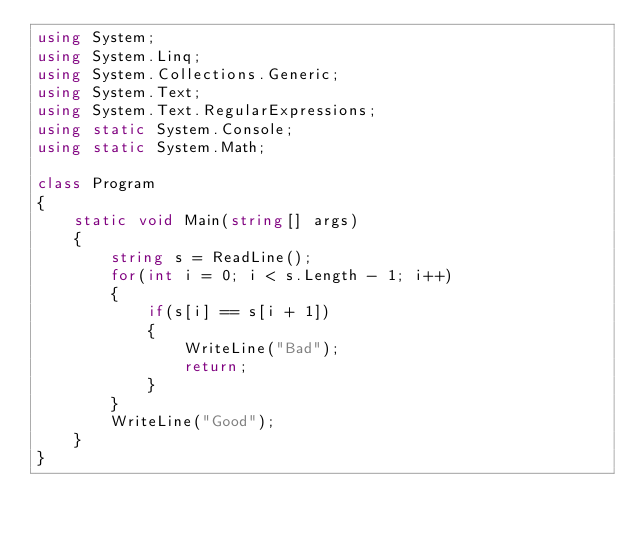Convert code to text. <code><loc_0><loc_0><loc_500><loc_500><_C#_>using System;
using System.Linq;
using System.Collections.Generic;
using System.Text;
using System.Text.RegularExpressions;
using static System.Console;
using static System.Math;

class Program
{
    static void Main(string[] args)
    {
        string s = ReadLine();
        for(int i = 0; i < s.Length - 1; i++)
        {
            if(s[i] == s[i + 1])
            {
                WriteLine("Bad");
                return;
            }
        }
        WriteLine("Good");
    }
}</code> 